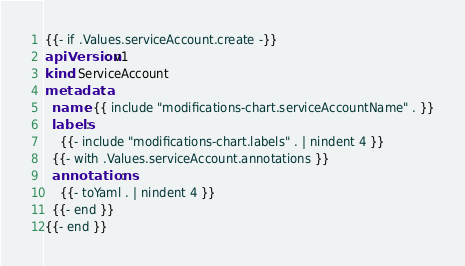<code> <loc_0><loc_0><loc_500><loc_500><_YAML_>{{- if .Values.serviceAccount.create -}}
apiVersion: v1
kind: ServiceAccount
metadata:
  name: {{ include "modifications-chart.serviceAccountName" . }}
  labels:
    {{- include "modifications-chart.labels" . | nindent 4 }}
  {{- with .Values.serviceAccount.annotations }}
  annotations:
    {{- toYaml . | nindent 4 }}
  {{- end }}
{{- end }}
</code> 